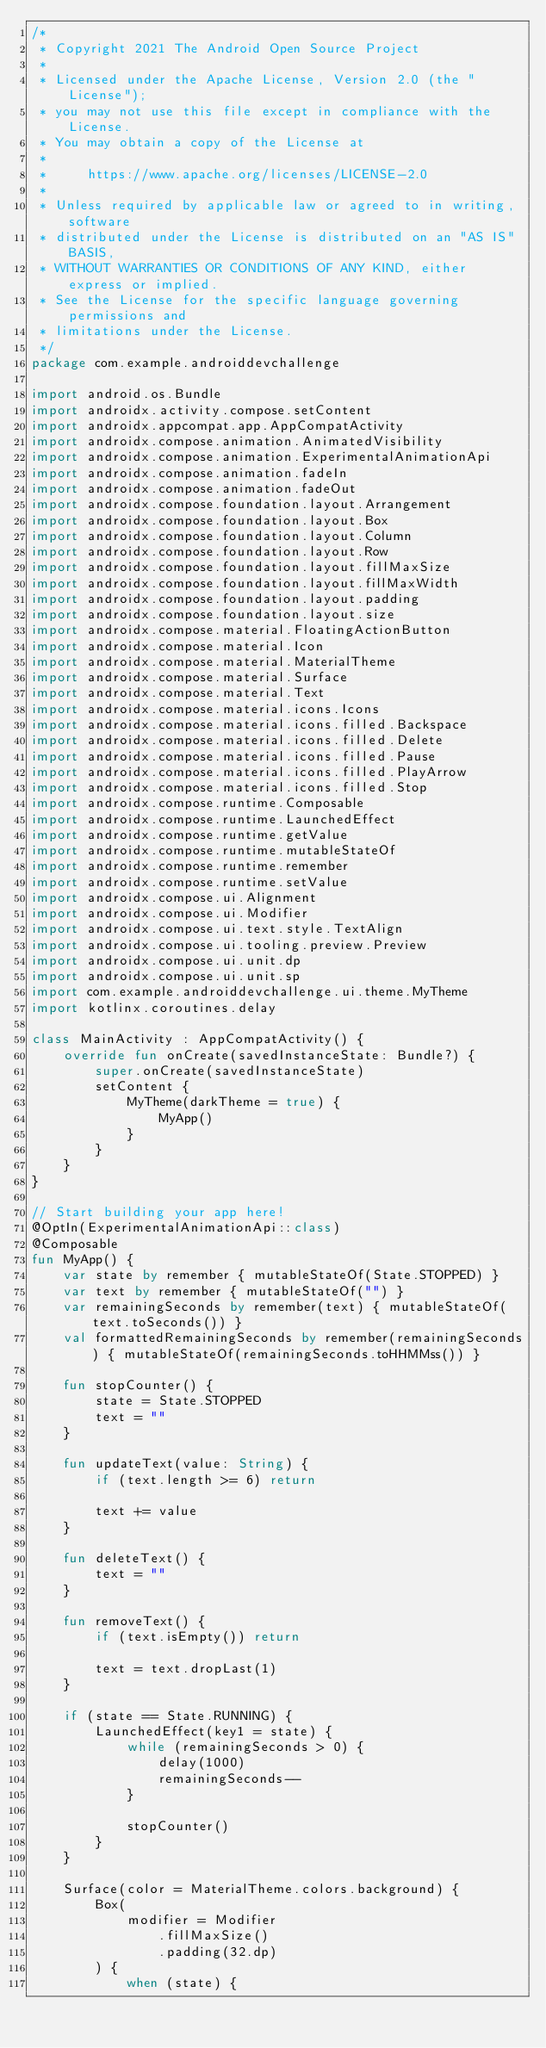Convert code to text. <code><loc_0><loc_0><loc_500><loc_500><_Kotlin_>/*
 * Copyright 2021 The Android Open Source Project
 *
 * Licensed under the Apache License, Version 2.0 (the "License");
 * you may not use this file except in compliance with the License.
 * You may obtain a copy of the License at
 *
 *     https://www.apache.org/licenses/LICENSE-2.0
 *
 * Unless required by applicable law or agreed to in writing, software
 * distributed under the License is distributed on an "AS IS" BASIS,
 * WITHOUT WARRANTIES OR CONDITIONS OF ANY KIND, either express or implied.
 * See the License for the specific language governing permissions and
 * limitations under the License.
 */
package com.example.androiddevchallenge

import android.os.Bundle
import androidx.activity.compose.setContent
import androidx.appcompat.app.AppCompatActivity
import androidx.compose.animation.AnimatedVisibility
import androidx.compose.animation.ExperimentalAnimationApi
import androidx.compose.animation.fadeIn
import androidx.compose.animation.fadeOut
import androidx.compose.foundation.layout.Arrangement
import androidx.compose.foundation.layout.Box
import androidx.compose.foundation.layout.Column
import androidx.compose.foundation.layout.Row
import androidx.compose.foundation.layout.fillMaxSize
import androidx.compose.foundation.layout.fillMaxWidth
import androidx.compose.foundation.layout.padding
import androidx.compose.foundation.layout.size
import androidx.compose.material.FloatingActionButton
import androidx.compose.material.Icon
import androidx.compose.material.MaterialTheme
import androidx.compose.material.Surface
import androidx.compose.material.Text
import androidx.compose.material.icons.Icons
import androidx.compose.material.icons.filled.Backspace
import androidx.compose.material.icons.filled.Delete
import androidx.compose.material.icons.filled.Pause
import androidx.compose.material.icons.filled.PlayArrow
import androidx.compose.material.icons.filled.Stop
import androidx.compose.runtime.Composable
import androidx.compose.runtime.LaunchedEffect
import androidx.compose.runtime.getValue
import androidx.compose.runtime.mutableStateOf
import androidx.compose.runtime.remember
import androidx.compose.runtime.setValue
import androidx.compose.ui.Alignment
import androidx.compose.ui.Modifier
import androidx.compose.ui.text.style.TextAlign
import androidx.compose.ui.tooling.preview.Preview
import androidx.compose.ui.unit.dp
import androidx.compose.ui.unit.sp
import com.example.androiddevchallenge.ui.theme.MyTheme
import kotlinx.coroutines.delay

class MainActivity : AppCompatActivity() {
    override fun onCreate(savedInstanceState: Bundle?) {
        super.onCreate(savedInstanceState)
        setContent {
            MyTheme(darkTheme = true) {
                MyApp()
            }
        }
    }
}

// Start building your app here!
@OptIn(ExperimentalAnimationApi::class)
@Composable
fun MyApp() {
    var state by remember { mutableStateOf(State.STOPPED) }
    var text by remember { mutableStateOf("") }
    var remainingSeconds by remember(text) { mutableStateOf(text.toSeconds()) }
    val formattedRemainingSeconds by remember(remainingSeconds) { mutableStateOf(remainingSeconds.toHHMMss()) }

    fun stopCounter() {
        state = State.STOPPED
        text = ""
    }

    fun updateText(value: String) {
        if (text.length >= 6) return

        text += value
    }

    fun deleteText() {
        text = ""
    }

    fun removeText() {
        if (text.isEmpty()) return

        text = text.dropLast(1)
    }

    if (state == State.RUNNING) {
        LaunchedEffect(key1 = state) {
            while (remainingSeconds > 0) {
                delay(1000)
                remainingSeconds--
            }

            stopCounter()
        }
    }

    Surface(color = MaterialTheme.colors.background) {
        Box(
            modifier = Modifier
                .fillMaxSize()
                .padding(32.dp)
        ) {
            when (state) {</code> 